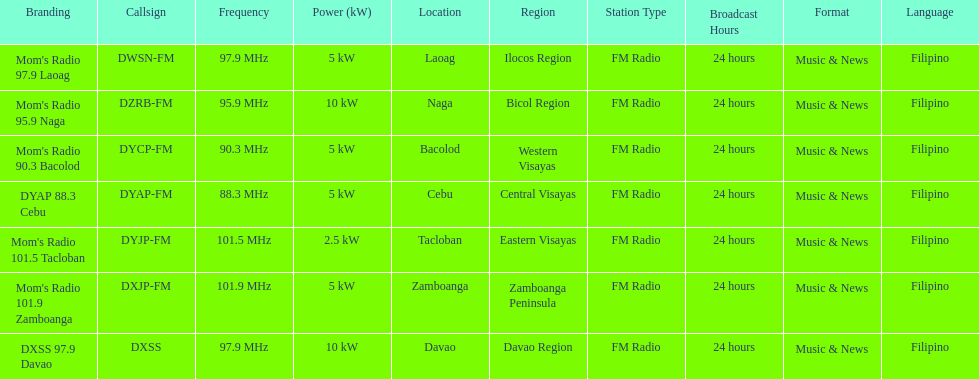What was the power in kilowatts of the davao radio? 10 kW. 